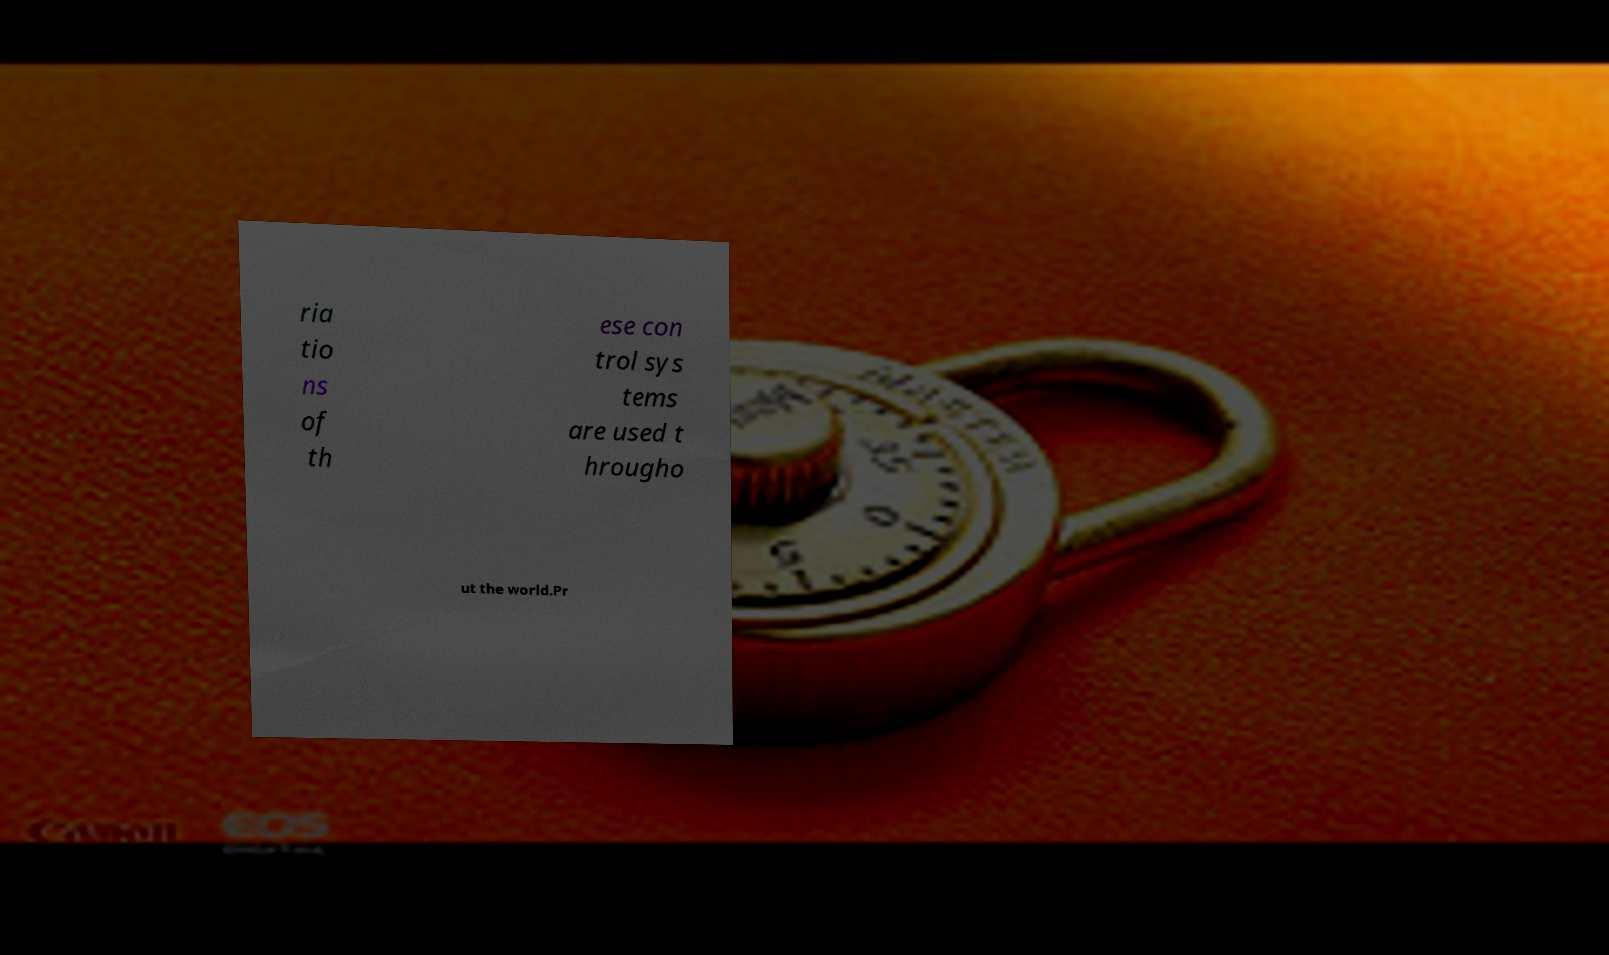Can you read and provide the text displayed in the image?This photo seems to have some interesting text. Can you extract and type it out for me? ria tio ns of th ese con trol sys tems are used t hrougho ut the world.Pr 